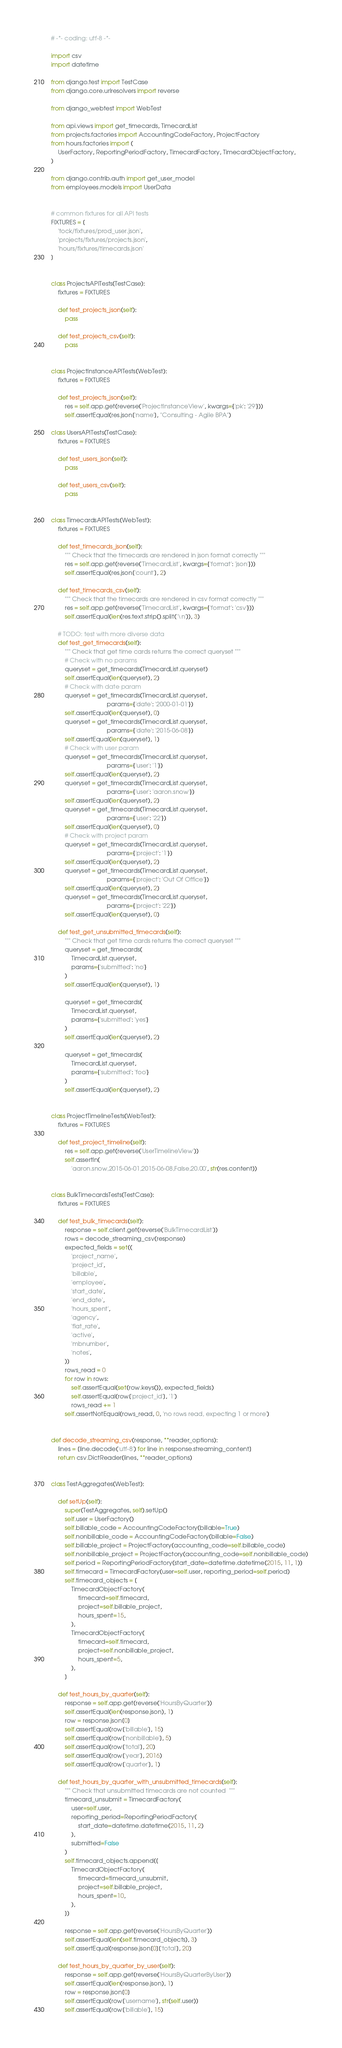<code> <loc_0><loc_0><loc_500><loc_500><_Python_># -*- coding: utf-8 -*-

import csv
import datetime

from django.test import TestCase
from django.core.urlresolvers import reverse

from django_webtest import WebTest

from api.views import get_timecards, TimecardList
from projects.factories import AccountingCodeFactory, ProjectFactory
from hours.factories import (
    UserFactory, ReportingPeriodFactory, TimecardFactory, TimecardObjectFactory,
)

from django.contrib.auth import get_user_model
from employees.models import UserData


# common fixtures for all API tests
FIXTURES = [
    'tock/fixtures/prod_user.json',
    'projects/fixtures/projects.json',
    'hours/fixtures/timecards.json'
]


class ProjectsAPITests(TestCase):
    fixtures = FIXTURES

    def test_projects_json(self):
        pass

    def test_projects_csv(self):
        pass


class ProjectInstanceAPITests(WebTest):
    fixtures = FIXTURES

    def test_projects_json(self):
        res = self.app.get(reverse('ProjectInstanceView', kwargs={'pk': '29'}))
        self.assertEqual(res.json['name'], "Consulting - Agile BPA")

class UsersAPITests(TestCase):
    fixtures = FIXTURES

    def test_users_json(self):
        pass

    def test_users_csv(self):
        pass


class TimecardsAPITests(WebTest):
    fixtures = FIXTURES

    def test_timecards_json(self):
        """ Check that the timecards are rendered in json format correctly """
        res = self.app.get(reverse('TimecardList', kwargs={'format': 'json'}))
        self.assertEqual(res.json['count'], 2)

    def test_timecards_csv(self):
        """ Check that the timecards are rendered in csv format correctly """
        res = self.app.get(reverse('TimecardList', kwargs={'format': 'csv'}))
        self.assertEqual(len(res.text.strip().split('\n')), 3)

    # TODO: test with more diverse data
    def test_get_timecards(self):
        """ Check that get time cards returns the correct queryset """
        # Check with no params
        queryset = get_timecards(TimecardList.queryset)
        self.assertEqual(len(queryset), 2)
        # Check with date param
        queryset = get_timecards(TimecardList.queryset,
                                 params={'date': '2000-01-01'})
        self.assertEqual(len(queryset), 0)
        queryset = get_timecards(TimecardList.queryset,
                                 params={'date': '2015-06-08'})
        self.assertEqual(len(queryset), 1)
        # Check with user param
        queryset = get_timecards(TimecardList.queryset,
                                 params={'user': '1'})
        self.assertEqual(len(queryset), 2)
        queryset = get_timecards(TimecardList.queryset,
                                 params={'user': 'aaron.snow'})
        self.assertEqual(len(queryset), 2)
        queryset = get_timecards(TimecardList.queryset,
                                 params={'user': '22'})
        self.assertEqual(len(queryset), 0)
        # Check with project param
        queryset = get_timecards(TimecardList.queryset,
                                 params={'project': '1'})
        self.assertEqual(len(queryset), 2)
        queryset = get_timecards(TimecardList.queryset,
                                 params={'project': 'Out Of Office'})
        self.assertEqual(len(queryset), 2)
        queryset = get_timecards(TimecardList.queryset,
                                 params={'project': '22'})
        self.assertEqual(len(queryset), 0)

    def test_get_unsubmitted_timecards(self):
        """ Check that get time cards returns the correct queryset """
        queryset = get_timecards(
            TimecardList.queryset,
            params={'submitted': 'no'}
        )
        self.assertEqual(len(queryset), 1)

        queryset = get_timecards(
            TimecardList.queryset,
            params={'submitted': 'yes'}
        )
        self.assertEqual(len(queryset), 2)

        queryset = get_timecards(
            TimecardList.queryset,
            params={'submitted': 'foo'}
        )
        self.assertEqual(len(queryset), 2)


class ProjectTimelineTests(WebTest):
    fixtures = FIXTURES

    def test_project_timeline(self):
        res = self.app.get(reverse('UserTimelineView'))
        self.assertIn(
            'aaron.snow,2015-06-01,2015-06-08,False,20.00', str(res.content))


class BulkTimecardsTests(TestCase):
    fixtures = FIXTURES

    def test_bulk_timecards(self):
        response = self.client.get(reverse('BulkTimecardList'))
        rows = decode_streaming_csv(response)
        expected_fields = set((
            'project_name',
            'project_id',
            'billable',
            'employee',
            'start_date',
            'end_date',
            'hours_spent',
            'agency',
            'flat_rate',
            'active',
            'mbnumber',
            'notes',
        ))
        rows_read = 0
        for row in rows:
            self.assertEqual(set(row.keys()), expected_fields)
            self.assertEqual(row['project_id'], '1')
            rows_read += 1
        self.assertNotEqual(rows_read, 0, 'no rows read, expecting 1 or more')


def decode_streaming_csv(response, **reader_options):
    lines = [line.decode('utf-8') for line in response.streaming_content]
    return csv.DictReader(lines, **reader_options)


class TestAggregates(WebTest):

    def setUp(self):
        super(TestAggregates, self).setUp()
        self.user = UserFactory()
        self.billable_code = AccountingCodeFactory(billable=True)
        self.nonbillable_code = AccountingCodeFactory(billable=False)
        self.billable_project = ProjectFactory(accounting_code=self.billable_code)
        self.nonbillable_project = ProjectFactory(accounting_code=self.nonbillable_code)
        self.period = ReportingPeriodFactory(start_date=datetime.datetime(2015, 11, 1))
        self.timecard = TimecardFactory(user=self.user, reporting_period=self.period)
        self.timecard_objects = [
            TimecardObjectFactory(
                timecard=self.timecard,
                project=self.billable_project,
                hours_spent=15,
            ),
            TimecardObjectFactory(
                timecard=self.timecard,
                project=self.nonbillable_project,
                hours_spent=5,
            ),
        ]

    def test_hours_by_quarter(self):
        response = self.app.get(reverse('HoursByQuarter'))
        self.assertEqual(len(response.json), 1)
        row = response.json[0]
        self.assertEqual(row['billable'], 15)
        self.assertEqual(row['nonbillable'], 5)
        self.assertEqual(row['total'], 20)
        self.assertEqual(row['year'], 2016)
        self.assertEqual(row['quarter'], 1)

    def test_hours_by_quarter_with_unsubmitted_timecards(self):
        """ Check that unsubmitted timecards are not counted  """
        timecard_unsubmit = TimecardFactory(
            user=self.user,
            reporting_period=ReportingPeriodFactory(
                start_date=datetime.datetime(2015, 11, 2)
            ),
            submitted=False
        )
        self.timecard_objects.append([
            TimecardObjectFactory(
                timecard=timecard_unsubmit,
                project=self.billable_project,
                hours_spent=10,
            ),
        ])

        response = self.app.get(reverse('HoursByQuarter'))
        self.assertEqual(len(self.timecard_objects), 3)
        self.assertEqual(response.json[0]['total'], 20)

    def test_hours_by_quarter_by_user(self):
        response = self.app.get(reverse('HoursByQuarterByUser'))
        self.assertEqual(len(response.json), 1)
        row = response.json[0]
        self.assertEqual(row['username'], str(self.user))
        self.assertEqual(row['billable'], 15)</code> 